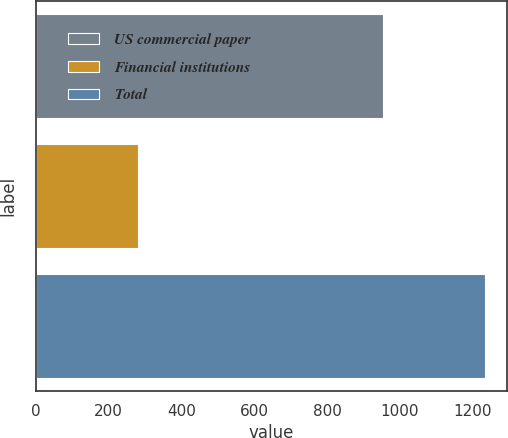Convert chart. <chart><loc_0><loc_0><loc_500><loc_500><bar_chart><fcel>US commercial paper<fcel>Financial institutions<fcel>Total<nl><fcel>954.7<fcel>279.4<fcel>1234.1<nl></chart> 